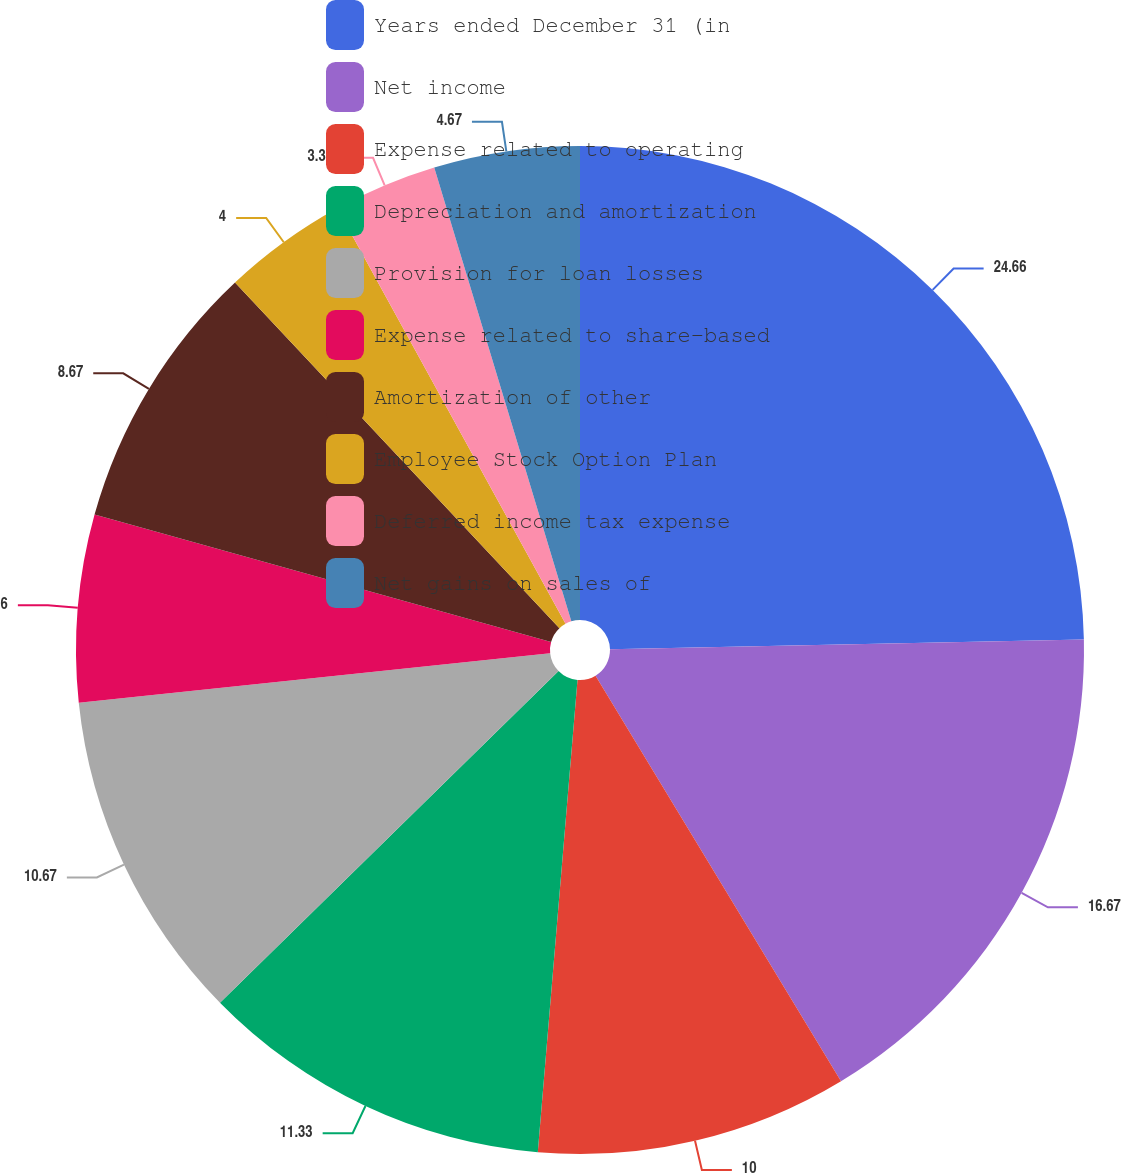Convert chart to OTSL. <chart><loc_0><loc_0><loc_500><loc_500><pie_chart><fcel>Years ended December 31 (in<fcel>Net income<fcel>Expense related to operating<fcel>Depreciation and amortization<fcel>Provision for loan losses<fcel>Expense related to share-based<fcel>Amortization of other<fcel>Employee Stock Option Plan<fcel>Deferred income tax expense<fcel>Net gains on sales of<nl><fcel>24.67%<fcel>16.67%<fcel>10.0%<fcel>11.33%<fcel>10.67%<fcel>6.0%<fcel>8.67%<fcel>4.0%<fcel>3.33%<fcel>4.67%<nl></chart> 